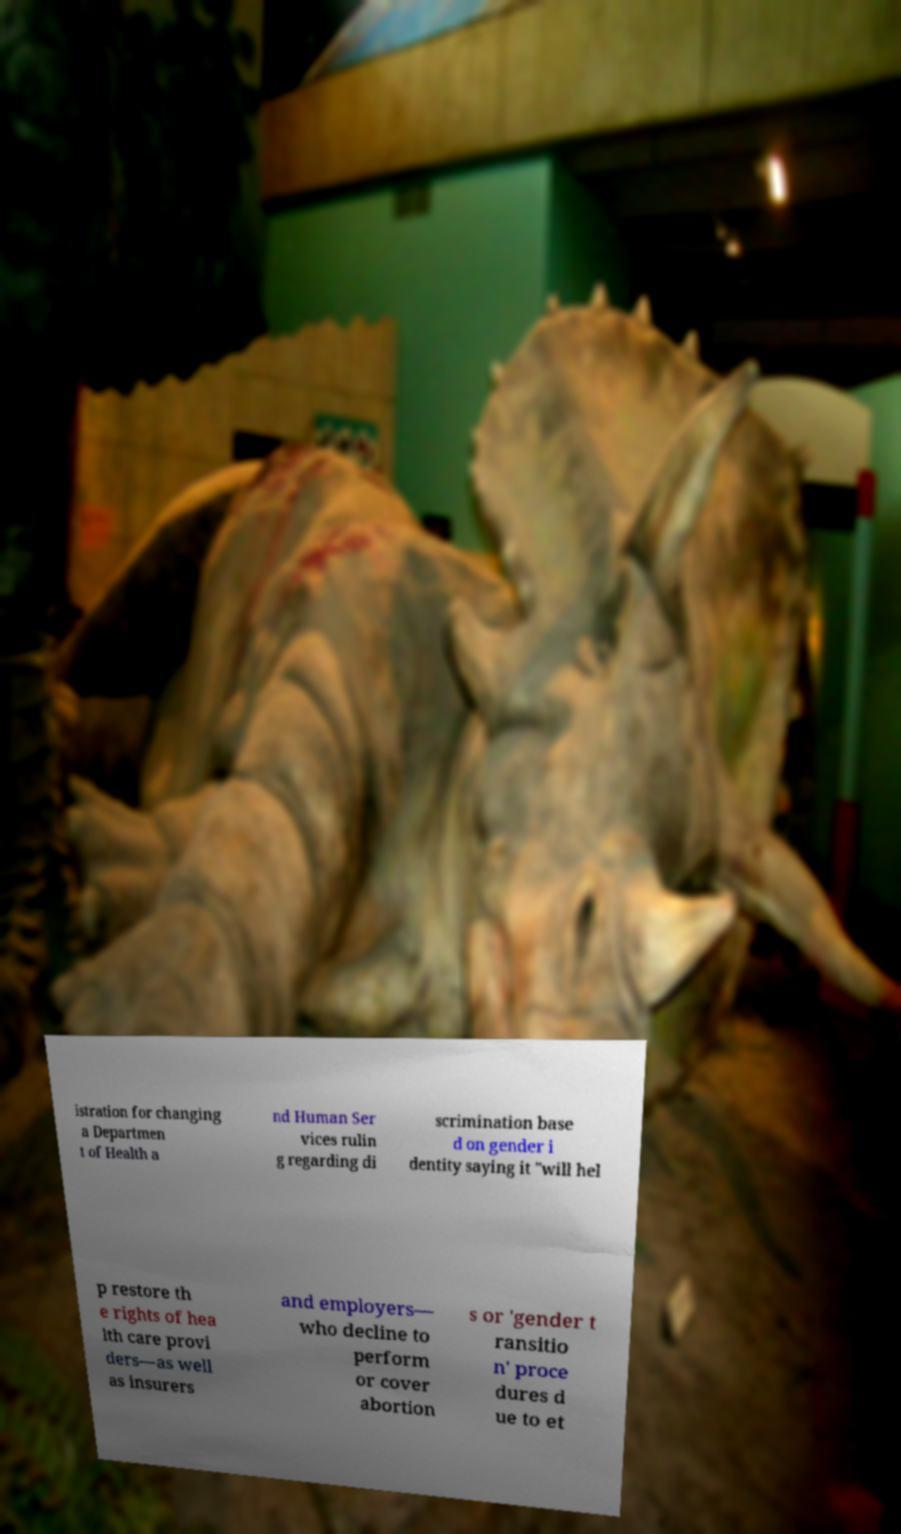There's text embedded in this image that I need extracted. Can you transcribe it verbatim? istration for changing a Departmen t of Health a nd Human Ser vices rulin g regarding di scrimination base d on gender i dentity saying it "will hel p restore th e rights of hea lth care provi ders—as well as insurers and employers— who decline to perform or cover abortion s or 'gender t ransitio n' proce dures d ue to et 